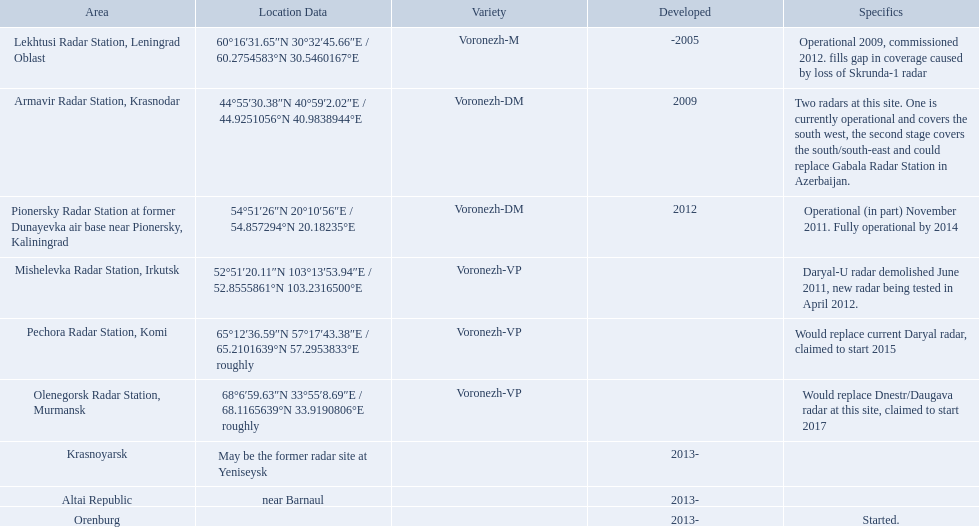Which voronezh radar has already started? Orenburg. Which radar would replace dnestr/daugava? Olenegorsk Radar Station, Murmansk. Which radar started in 2015? Pechora Radar Station, Komi. Which column has the coordinates starting with 60 deg? 60°16′31.65″N 30°32′45.66″E﻿ / ﻿60.2754583°N 30.5460167°E. What is the location in the same row as that column? Lekhtusi Radar Station, Leningrad Oblast. What are all of the locations? Lekhtusi Radar Station, Leningrad Oblast, Armavir Radar Station, Krasnodar, Pionersky Radar Station at former Dunayevka air base near Pionersky, Kaliningrad, Mishelevka Radar Station, Irkutsk, Pechora Radar Station, Komi, Olenegorsk Radar Station, Murmansk, Krasnoyarsk, Altai Republic, Orenburg. And which location's coordinates are 60deg16'31.65''n 30deg32'45.66''e / 60.2754583degn 30.5460167dege? Lekhtusi Radar Station, Leningrad Oblast. 